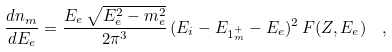<formula> <loc_0><loc_0><loc_500><loc_500>\frac { d n _ { m } } { d E _ { e } } = \frac { E _ { e } \, \sqrt { E _ { e } ^ { 2 } - m _ { e } ^ { 2 } } } { 2 \pi ^ { 3 } } \, ( E _ { i } - E _ { 1 ^ { + } _ { m } } - E _ { e } ) ^ { 2 } \, F ( Z , E _ { e } ) \ \ ,</formula> 